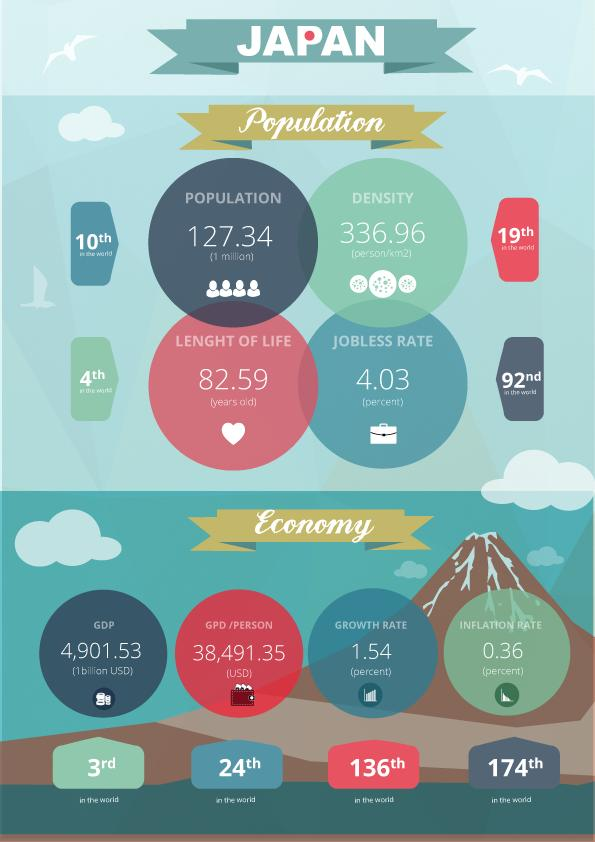Draw attention to some important aspects in this diagram. The jobless rate in Japan is 4.03%. Japan's GDP is 4,901.53 The life expectancy in Japan is 82.59 years, on average. 